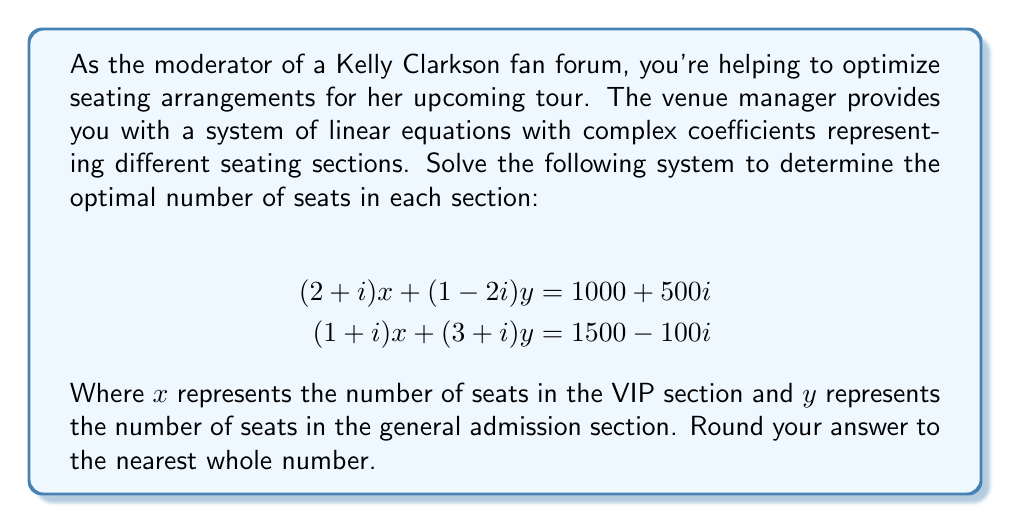Teach me how to tackle this problem. Let's solve this system of linear equations with complex coefficients step by step:

1) First, let's rewrite the equations:
   Equation 1: $(2+i)x + (1-2i)y = 1000+500i$
   Equation 2: $(1+i)x + (3+i)y = 1500-100i$

2) We'll use the elimination method. Multiply equation 1 by $(3+i)$ and equation 2 by $-(1-2i)$:

   $(3+i)[(2+i)x + (1-2i)y = 1000+500i]$
   $-(1-2i)[(1+i)x + (3+i)y = 1500-100i]$

3) Expanding these:
   $[(6+5i)x + (3-5i)y = 3000+2500i]$
   $[(-1-3i)x + (-3-5i)y = -1500+200i]$

4) Adding these equations eliminates $y$:
   $(5+2i)x = 1500+2700i$

5) To solve for $x$, multiply both sides by the complex conjugate of $(5+2i)$:
   $(5-2i)(5+2i)x = (5-2i)(1500+2700i)$
   $(29)x = 7500+9900i+6000i-3600 = 3900+15900i$

6) Therefore:
   $x = \frac{3900+15900i}{29} \approx 134.48+548.28i$

7) Substitute this value of $x$ back into equation 1:
   $(2+i)(134.48+548.28i) + (1-2i)y = 1000+500i$
   $-280.08+831.24i + (1-2i)y = 1000+500i$

8) Solving for $y$:
   $(1-2i)y = 1280.08-331.24i$
   $y = \frac{1280.08-331.24i}{1-2i} \cdot \frac{1+2i}{1+2i} = \frac{617.6+2228.92i}{5} \approx 123.52+445.78i$

9) Since we need real values for the number of seats, we'll take the real parts and round to the nearest whole number.
Answer: VIP section (x): 134 seats
General admission section (y): 124 seats 